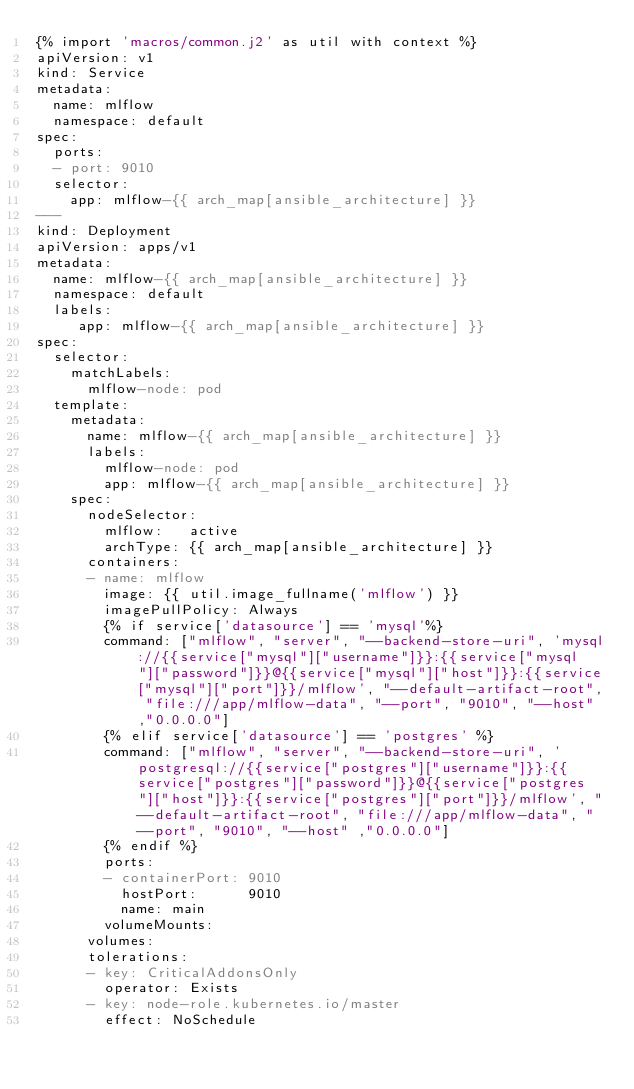<code> <loc_0><loc_0><loc_500><loc_500><_YAML_>{% import 'macros/common.j2' as util with context %}
apiVersion: v1
kind: Service
metadata:
  name: mlflow
  namespace: default
spec:
  ports:
  - port: 9010
  selector:
    app: mlflow-{{ arch_map[ansible_architecture] }}
---
kind: Deployment
apiVersion: apps/v1
metadata:
  name: mlflow-{{ arch_map[ansible_architecture] }}
  namespace: default
  labels:
     app: mlflow-{{ arch_map[ansible_architecture] }}
spec:
  selector:
    matchLabels:
      mlflow-node: pod
  template:
    metadata:
      name: mlflow-{{ arch_map[ansible_architecture] }}
      labels:
        mlflow-node: pod
        app: mlflow-{{ arch_map[ansible_architecture] }}
    spec:
      nodeSelector:
        mlflow:   active
        archType: {{ arch_map[ansible_architecture] }}
      containers:
      - name: mlflow
        image: {{ util.image_fullname('mlflow') }}
        imagePullPolicy: Always
        {% if service['datasource'] == 'mysql'%}
        command: ["mlflow", "server", "--backend-store-uri", 'mysql://{{service["mysql"]["username"]}}:{{service["mysql"]["password"]}}@{{service["mysql"]["host"]}}:{{service["mysql"]["port"]}}/mlflow', "--default-artifact-root", "file:///app/mlflow-data", "--port", "9010", "--host" ,"0.0.0.0"]
        {% elif service['datasource'] == 'postgres' %}
        command: ["mlflow", "server", "--backend-store-uri", 'postgresql://{{service["postgres"]["username"]}}:{{service["postgres"]["password"]}}@{{service["postgres"]["host"]}}:{{service["postgres"]["port"]}}/mlflow', "--default-artifact-root", "file:///app/mlflow-data", "--port", "9010", "--host" ,"0.0.0.0"]
        {% endif %}
        ports:
        - containerPort: 9010
          hostPort:      9010
          name: main
        volumeMounts:
      volumes:
      tolerations:
      - key: CriticalAddonsOnly
        operator: Exists
      - key: node-role.kubernetes.io/master
        effect: NoSchedule

</code> 